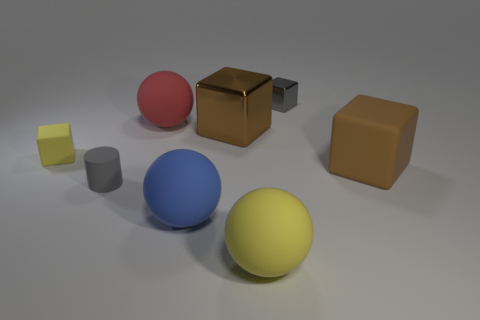Which objects in the scene could serve a functional purpose, and what might that be? The large brown cube could be a simple representation of functional furniture, like a table or storage box. The spheres and cylinders, depending on their size and material, might represent toys or decorative elements within a room, serving both aesthetic and playful functions. What mood does this arrangement convey? The arrangement has a minimalist, almost clinical quality which could suggest calmness and order. The balanced spacing between the objects and the neutral background contribute to a feeling of serenity and modernist simplicity. 